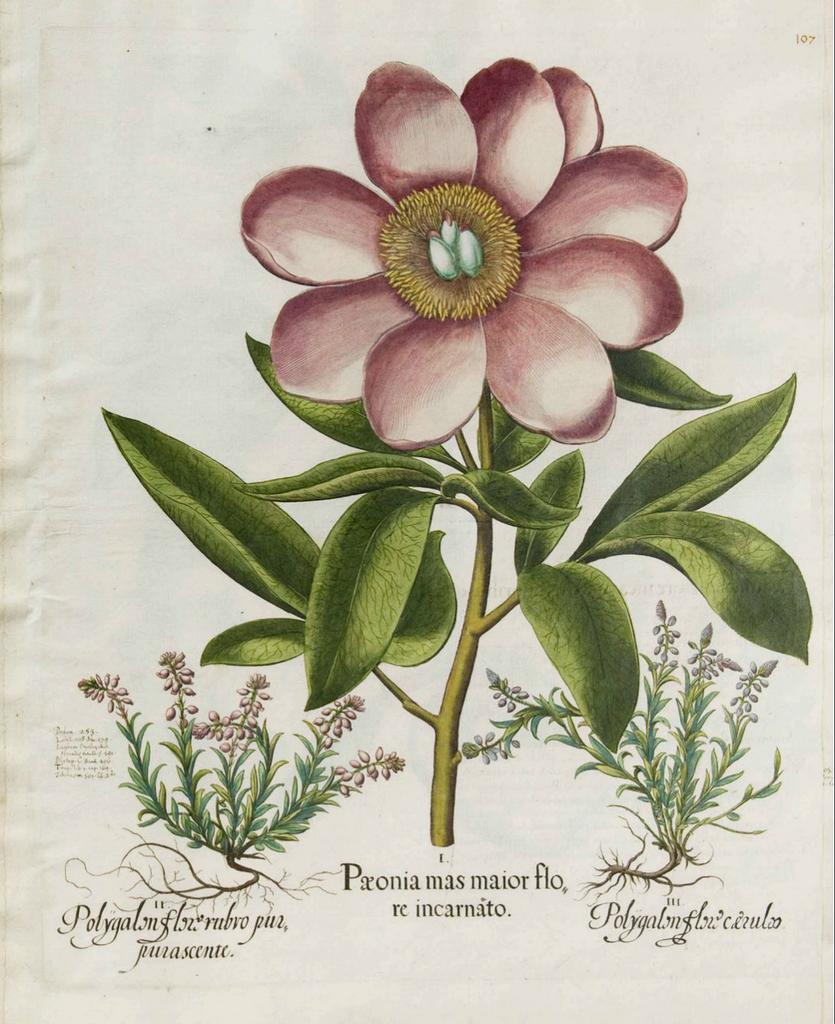In one or two sentences, can you explain what this image depicts? In the image there is a stem with leaves and pink flower. At the left corner there is a plant with leaves and flower. And at the right corner of the image also there is a plant with leaves and flower. At the bottom of the image there is something written on it. 